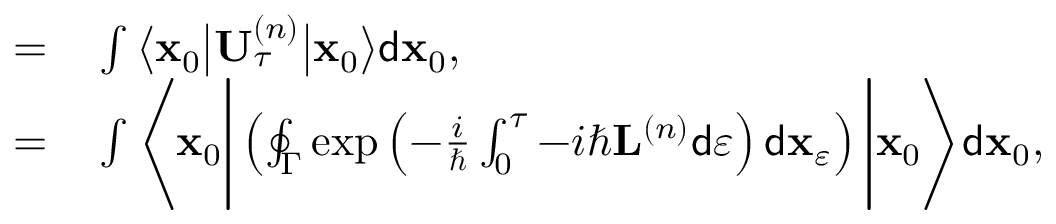<formula> <loc_0><loc_0><loc_500><loc_500>\begin{array} { r l } { = } & \int \left \langle x _ { 0 } \left | U _ { \tau } ^ { \left ( n \right ) } \right | x _ { 0 } \right \rangle d x _ { 0 } , } \\ { = } & \int \left \langle x _ { 0 } \left | \left ( \oint _ { \Gamma } \exp \left ( - \frac { i } { } \int _ { 0 } ^ { \tau } - i \hbar { L } ^ { \left ( n \right ) } d \varepsilon \right ) d x _ { \varepsilon } \right ) \right | x _ { 0 } \right \rangle d x _ { 0 } , } \end{array}</formula> 